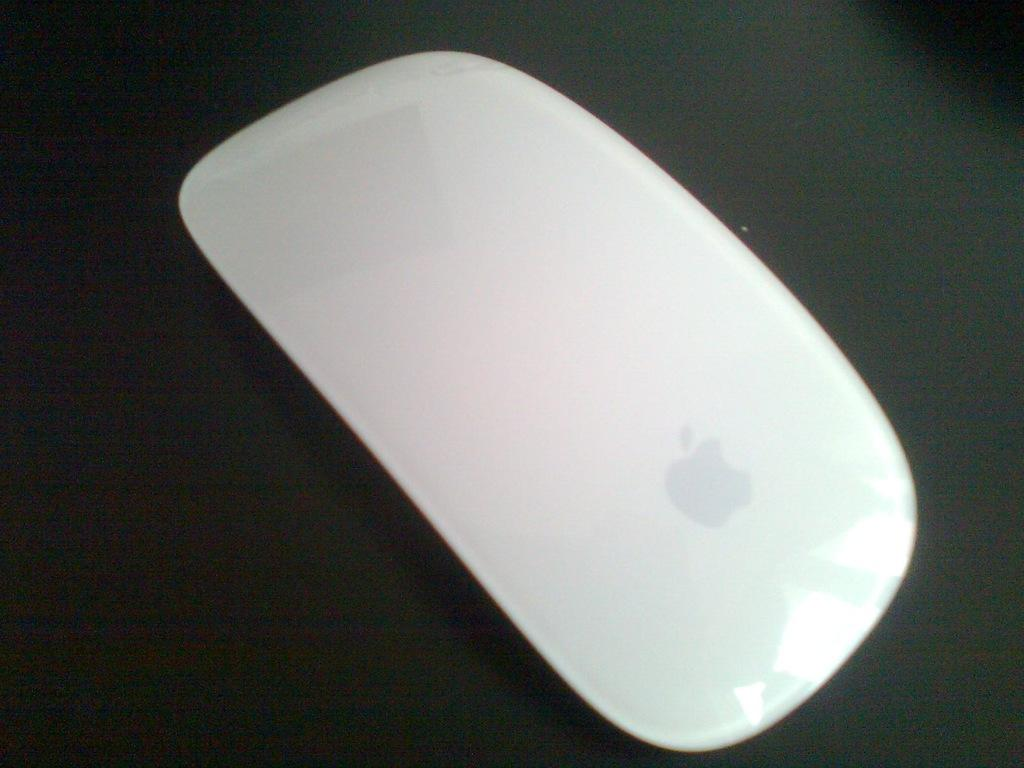What type of animal is in the image? There is a mouse in the image. What is the color of the surface the mouse is on? The mouse is on a black surface. What type of coal is being used by the mouse in the image? There is no coal present in the image, and the mouse is not using any coal. 